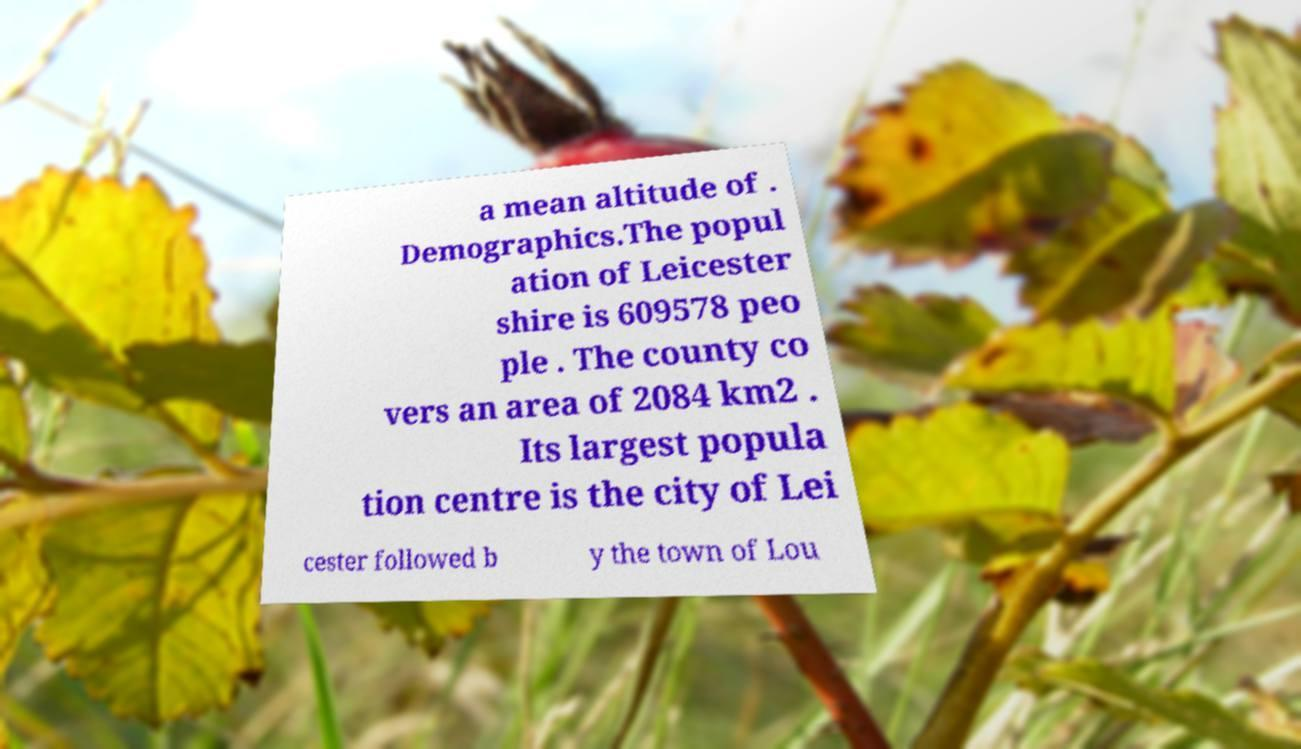Please read and relay the text visible in this image. What does it say? a mean altitude of . Demographics.The popul ation of Leicester shire is 609578 peo ple . The county co vers an area of 2084 km2 . Its largest popula tion centre is the city of Lei cester followed b y the town of Lou 